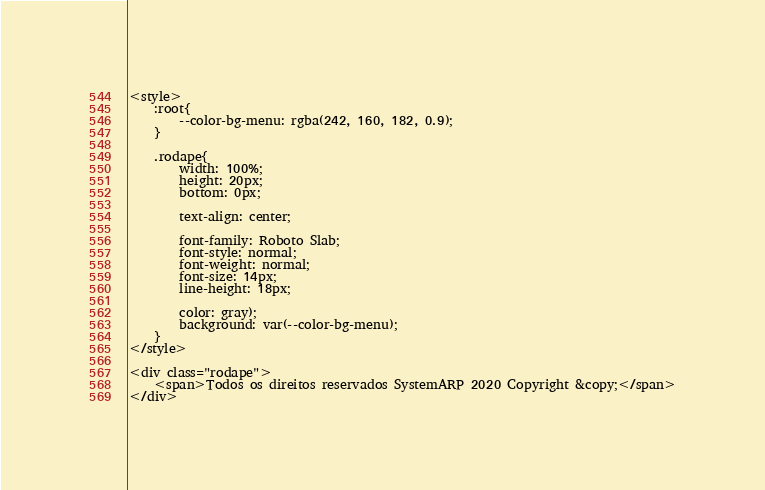Convert code to text. <code><loc_0><loc_0><loc_500><loc_500><_PHP_><style>
	:root{
		--color-bg-menu: rgba(242, 160, 182, 0.9);
	}

	.rodape{
		width: 100%;
		height: 20px;
		bottom: 0px;

		text-align: center;

		font-family: Roboto Slab;
		font-style: normal;
		font-weight: normal;
		font-size: 14px;
		line-height: 18px;

		color: gray);
		background: var(--color-bg-menu);
	}
</style>

<div class="rodape">
	<span>Todos os direitos reservados SystemARP 2020 Copyright &copy;</span>
</div></code> 